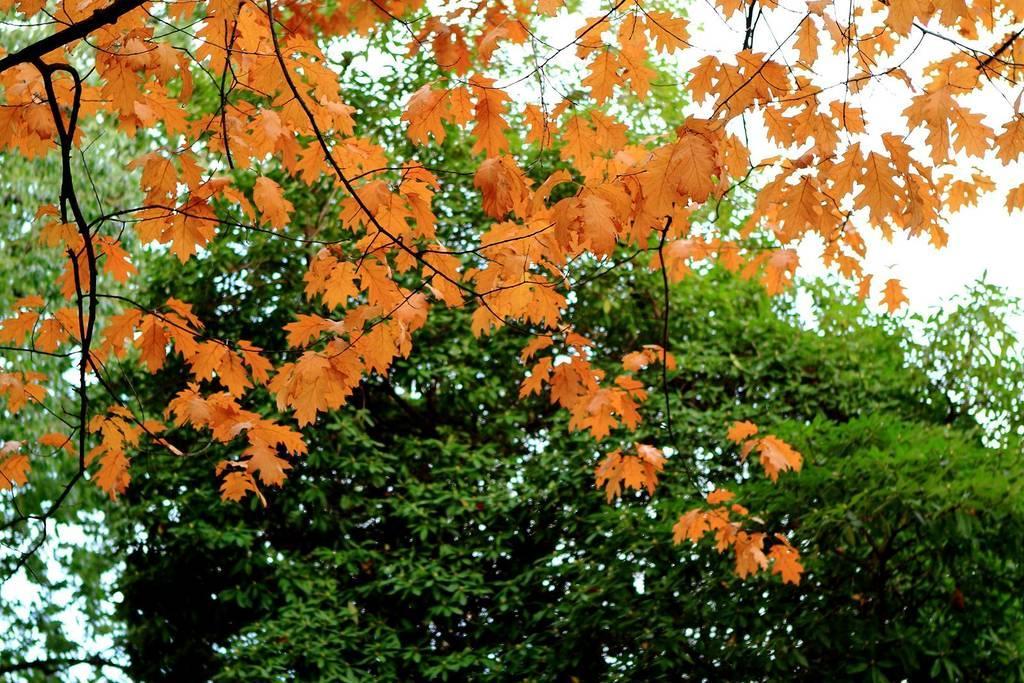How would you summarize this image in a sentence or two? In this picture I can see there are some trees and it has orange leaves. the sky is clear. 